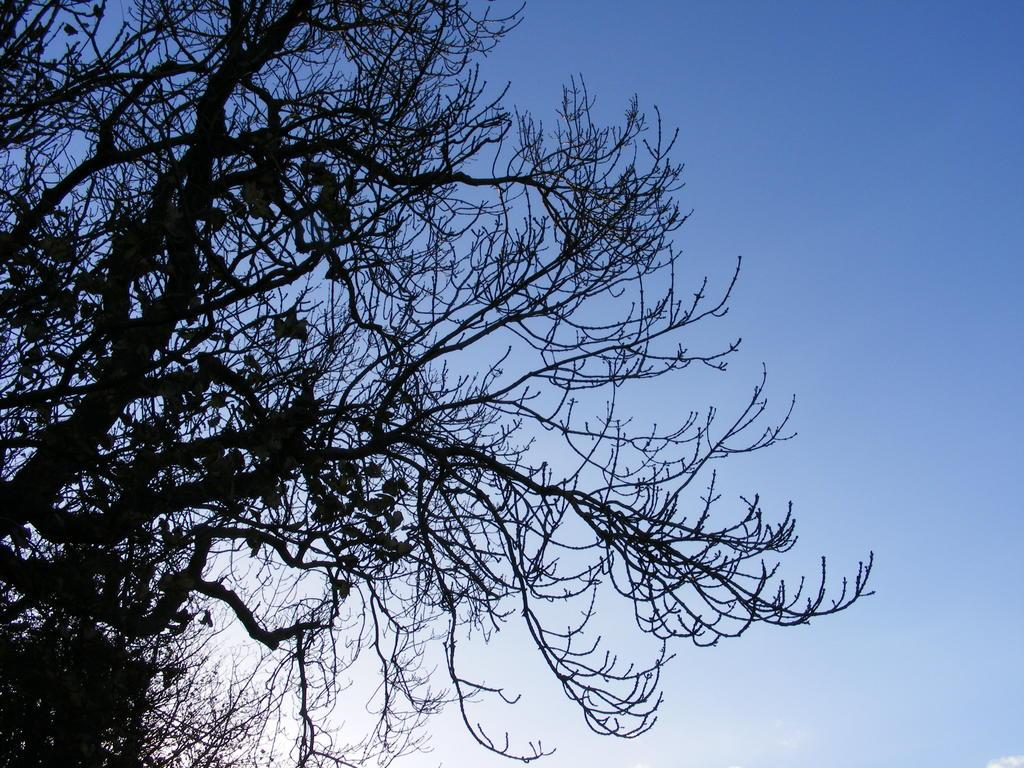What type of vegetation is on the left side of the image? There are trees on the left side of the image. What can be seen in the background of the image? The sky is visible in the background of the image. Can you see a blade being used to cut the trees in the image? There is no blade or any cutting activity visible in the image; it only features trees and the sky. How many clouds are present in the image? The provided facts do not mention any clouds, so we cannot determine the number of clouds present in the image. 